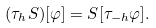Convert formula to latex. <formula><loc_0><loc_0><loc_500><loc_500>( \tau _ { h } S ) [ \varphi ] = S [ \tau _ { - h } \varphi ] .</formula> 